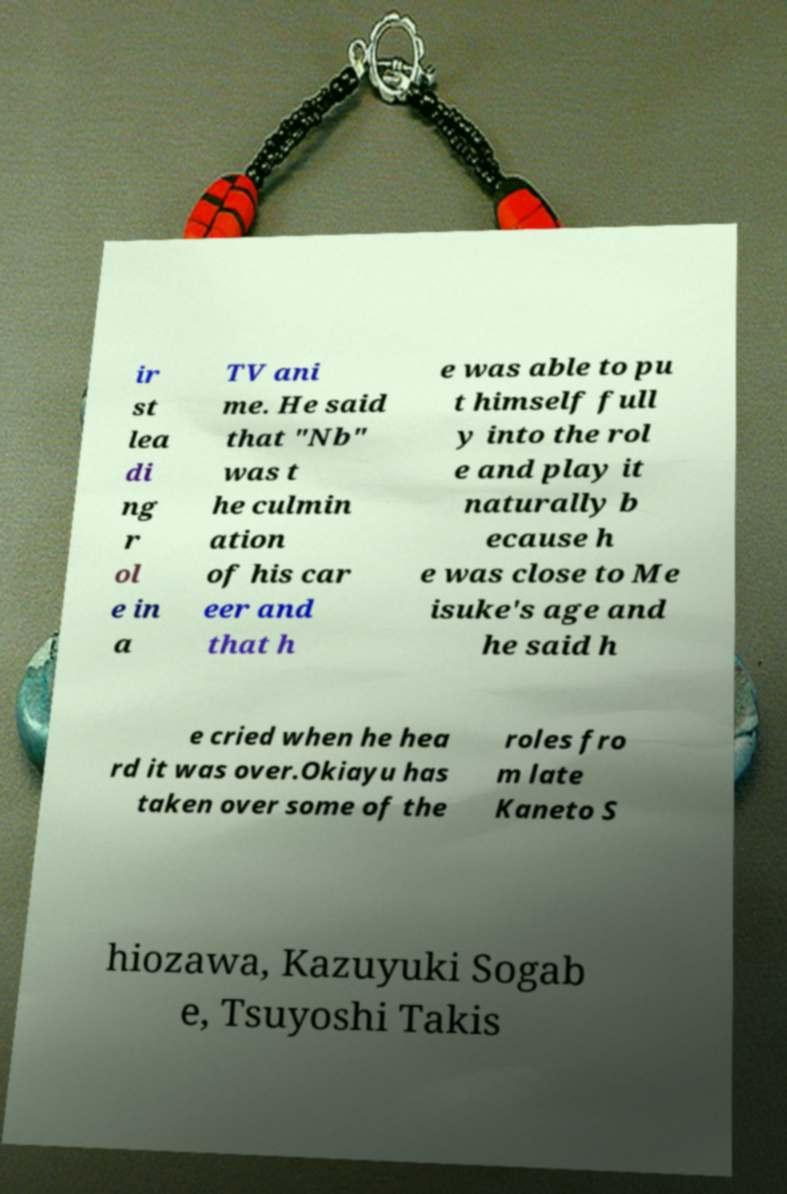I need the written content from this picture converted into text. Can you do that? ir st lea di ng r ol e in a TV ani me. He said that "Nb" was t he culmin ation of his car eer and that h e was able to pu t himself full y into the rol e and play it naturally b ecause h e was close to Me isuke's age and he said h e cried when he hea rd it was over.Okiayu has taken over some of the roles fro m late Kaneto S hiozawa, Kazuyuki Sogab e, Tsuyoshi Takis 